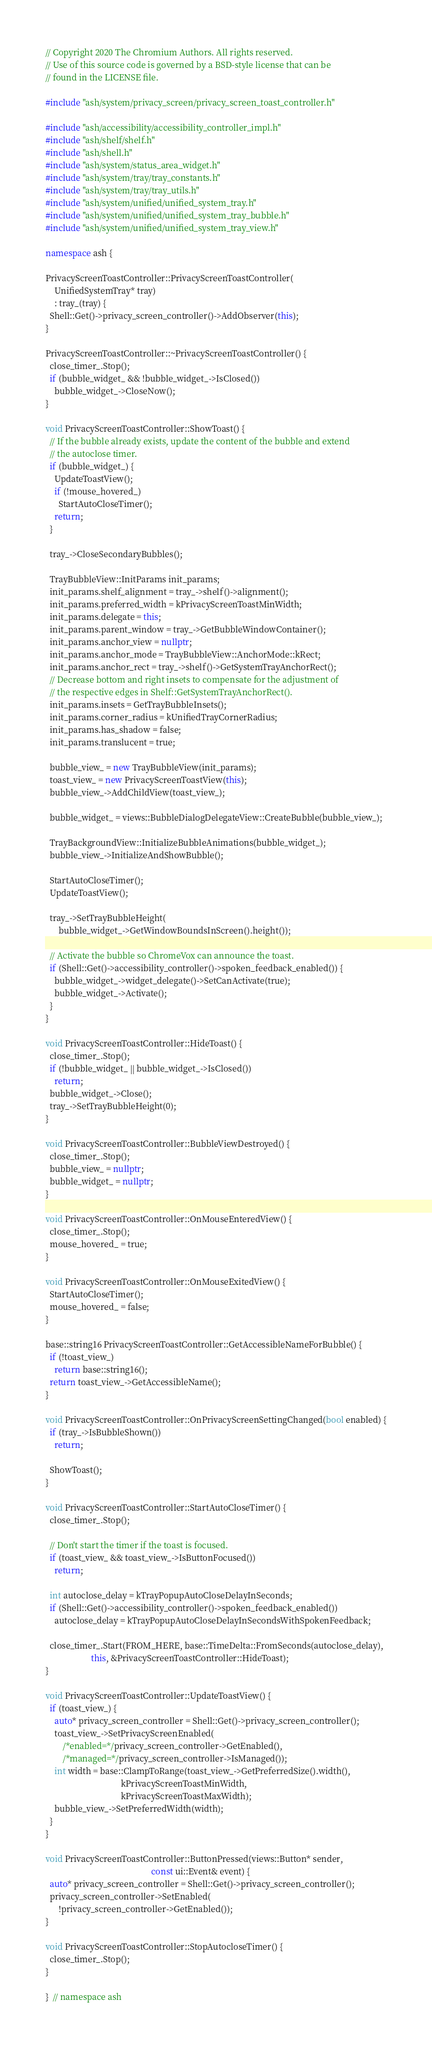<code> <loc_0><loc_0><loc_500><loc_500><_C++_>// Copyright 2020 The Chromium Authors. All rights reserved.
// Use of this source code is governed by a BSD-style license that can be
// found in the LICENSE file.

#include "ash/system/privacy_screen/privacy_screen_toast_controller.h"

#include "ash/accessibility/accessibility_controller_impl.h"
#include "ash/shelf/shelf.h"
#include "ash/shell.h"
#include "ash/system/status_area_widget.h"
#include "ash/system/tray/tray_constants.h"
#include "ash/system/tray/tray_utils.h"
#include "ash/system/unified/unified_system_tray.h"
#include "ash/system/unified/unified_system_tray_bubble.h"
#include "ash/system/unified/unified_system_tray_view.h"

namespace ash {

PrivacyScreenToastController::PrivacyScreenToastController(
    UnifiedSystemTray* tray)
    : tray_(tray) {
  Shell::Get()->privacy_screen_controller()->AddObserver(this);
}

PrivacyScreenToastController::~PrivacyScreenToastController() {
  close_timer_.Stop();
  if (bubble_widget_ && !bubble_widget_->IsClosed())
    bubble_widget_->CloseNow();
}

void PrivacyScreenToastController::ShowToast() {
  // If the bubble already exists, update the content of the bubble and extend
  // the autoclose timer.
  if (bubble_widget_) {
    UpdateToastView();
    if (!mouse_hovered_)
      StartAutoCloseTimer();
    return;
  }

  tray_->CloseSecondaryBubbles();

  TrayBubbleView::InitParams init_params;
  init_params.shelf_alignment = tray_->shelf()->alignment();
  init_params.preferred_width = kPrivacyScreenToastMinWidth;
  init_params.delegate = this;
  init_params.parent_window = tray_->GetBubbleWindowContainer();
  init_params.anchor_view = nullptr;
  init_params.anchor_mode = TrayBubbleView::AnchorMode::kRect;
  init_params.anchor_rect = tray_->shelf()->GetSystemTrayAnchorRect();
  // Decrease bottom and right insets to compensate for the adjustment of
  // the respective edges in Shelf::GetSystemTrayAnchorRect().
  init_params.insets = GetTrayBubbleInsets();
  init_params.corner_radius = kUnifiedTrayCornerRadius;
  init_params.has_shadow = false;
  init_params.translucent = true;

  bubble_view_ = new TrayBubbleView(init_params);
  toast_view_ = new PrivacyScreenToastView(this);
  bubble_view_->AddChildView(toast_view_);

  bubble_widget_ = views::BubbleDialogDelegateView::CreateBubble(bubble_view_);

  TrayBackgroundView::InitializeBubbleAnimations(bubble_widget_);
  bubble_view_->InitializeAndShowBubble();

  StartAutoCloseTimer();
  UpdateToastView();

  tray_->SetTrayBubbleHeight(
      bubble_widget_->GetWindowBoundsInScreen().height());

  // Activate the bubble so ChromeVox can announce the toast.
  if (Shell::Get()->accessibility_controller()->spoken_feedback_enabled()) {
    bubble_widget_->widget_delegate()->SetCanActivate(true);
    bubble_widget_->Activate();
  }
}

void PrivacyScreenToastController::HideToast() {
  close_timer_.Stop();
  if (!bubble_widget_ || bubble_widget_->IsClosed())
    return;
  bubble_widget_->Close();
  tray_->SetTrayBubbleHeight(0);
}

void PrivacyScreenToastController::BubbleViewDestroyed() {
  close_timer_.Stop();
  bubble_view_ = nullptr;
  bubble_widget_ = nullptr;
}

void PrivacyScreenToastController::OnMouseEnteredView() {
  close_timer_.Stop();
  mouse_hovered_ = true;
}

void PrivacyScreenToastController::OnMouseExitedView() {
  StartAutoCloseTimer();
  mouse_hovered_ = false;
}

base::string16 PrivacyScreenToastController::GetAccessibleNameForBubble() {
  if (!toast_view_)
    return base::string16();
  return toast_view_->GetAccessibleName();
}

void PrivacyScreenToastController::OnPrivacyScreenSettingChanged(bool enabled) {
  if (tray_->IsBubbleShown())
    return;

  ShowToast();
}

void PrivacyScreenToastController::StartAutoCloseTimer() {
  close_timer_.Stop();

  // Don't start the timer if the toast is focused.
  if (toast_view_ && toast_view_->IsButtonFocused())
    return;

  int autoclose_delay = kTrayPopupAutoCloseDelayInSeconds;
  if (Shell::Get()->accessibility_controller()->spoken_feedback_enabled())
    autoclose_delay = kTrayPopupAutoCloseDelayInSecondsWithSpokenFeedback;

  close_timer_.Start(FROM_HERE, base::TimeDelta::FromSeconds(autoclose_delay),
                     this, &PrivacyScreenToastController::HideToast);
}

void PrivacyScreenToastController::UpdateToastView() {
  if (toast_view_) {
    auto* privacy_screen_controller = Shell::Get()->privacy_screen_controller();
    toast_view_->SetPrivacyScreenEnabled(
        /*enabled=*/privacy_screen_controller->GetEnabled(),
        /*managed=*/privacy_screen_controller->IsManaged());
    int width = base::ClampToRange(toast_view_->GetPreferredSize().width(),
                                   kPrivacyScreenToastMinWidth,
                                   kPrivacyScreenToastMaxWidth);
    bubble_view_->SetPreferredWidth(width);
  }
}

void PrivacyScreenToastController::ButtonPressed(views::Button* sender,
                                                 const ui::Event& event) {
  auto* privacy_screen_controller = Shell::Get()->privacy_screen_controller();
  privacy_screen_controller->SetEnabled(
      !privacy_screen_controller->GetEnabled());
}

void PrivacyScreenToastController::StopAutocloseTimer() {
  close_timer_.Stop();
}

}  // namespace ash
</code> 